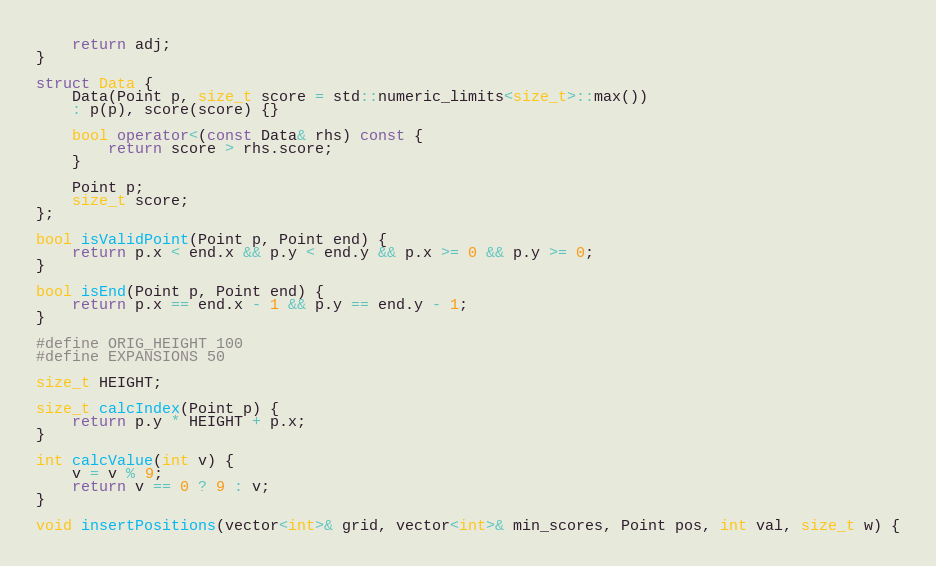Convert code to text. <code><loc_0><loc_0><loc_500><loc_500><_C++_>	return adj;
}

struct Data {
	Data(Point p, size_t score = std::numeric_limits<size_t>::max())
	: p(p), score(score) {}

	bool operator<(const Data& rhs) const {
		return score > rhs.score;
	}

	Point p;
	size_t score;
};

bool isValidPoint(Point p, Point end) {
	return p.x < end.x && p.y < end.y && p.x >= 0 && p.y >= 0;
}

bool isEnd(Point p, Point end) {
	return p.x == end.x - 1 && p.y == end.y - 1;
}

#define ORIG_HEIGHT 100
#define EXPANSIONS 50

size_t HEIGHT;

size_t calcIndex(Point p) {
	return p.y * HEIGHT + p.x;
}

int calcValue(int v) {
	v = v % 9;
	return v == 0 ? 9 : v;
}

void insertPositions(vector<int>& grid, vector<int>& min_scores, Point pos, int val, size_t w) {</code> 